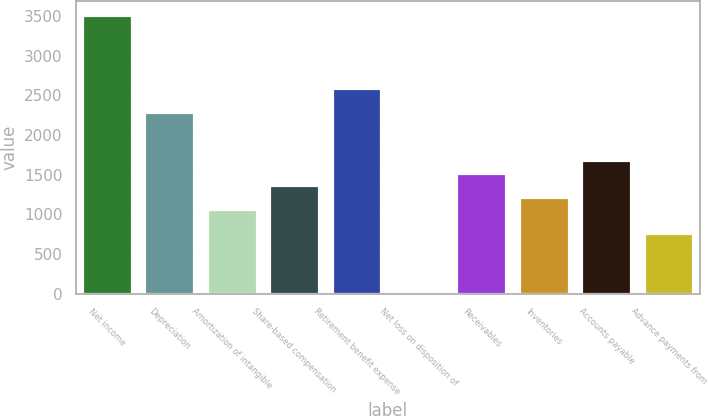Convert chart. <chart><loc_0><loc_0><loc_500><loc_500><bar_chart><fcel>Net income<fcel>Depreciation<fcel>Amortization of intangible<fcel>Share-based compensation<fcel>Retirement benefit expense<fcel>Net loss on disposition of<fcel>Receivables<fcel>Inventories<fcel>Accounts payable<fcel>Advance payments from<nl><fcel>3510.59<fcel>2289.55<fcel>1068.51<fcel>1373.77<fcel>2594.81<fcel>0.1<fcel>1526.4<fcel>1221.14<fcel>1679.03<fcel>763.25<nl></chart> 